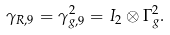Convert formula to latex. <formula><loc_0><loc_0><loc_500><loc_500>\gamma _ { R , 9 } = \gamma _ { g , 9 } ^ { 2 } = I _ { 2 } \otimes \Gamma _ { g } ^ { 2 } .</formula> 